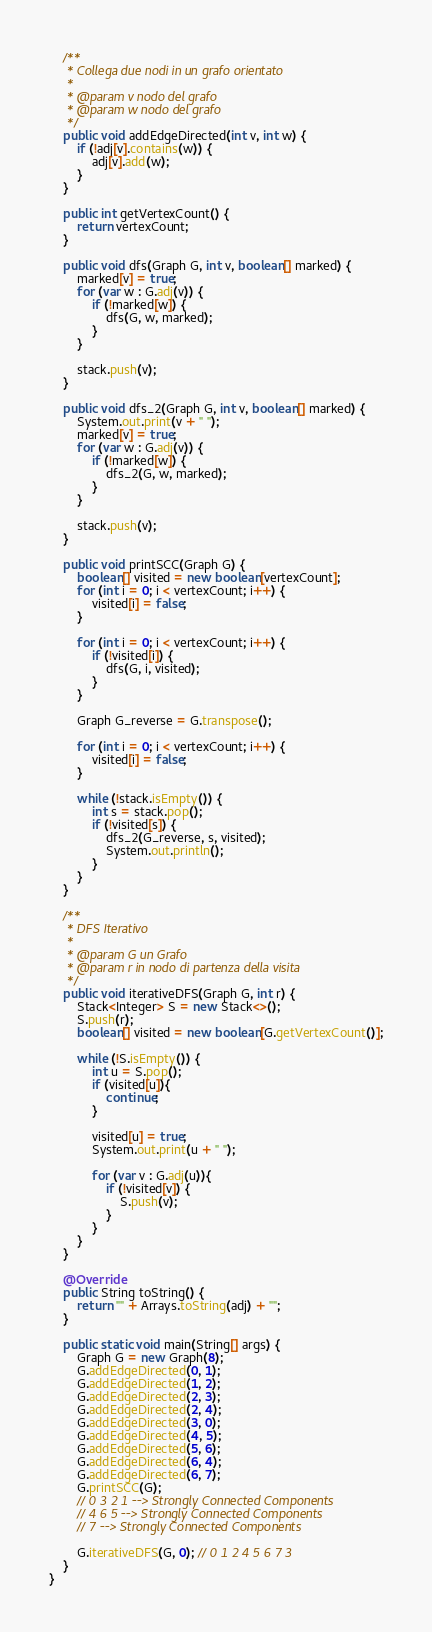<code> <loc_0><loc_0><loc_500><loc_500><_Java_>    /**
     * Collega due nodi in un grafo orientato
     *
     * @param v nodo del grafo
     * @param w nodo del grafo
     */
    public void addEdgeDirected(int v, int w) {
        if (!adj[v].contains(w)) {
            adj[v].add(w);
        }
    }

    public int getVertexCount() {
        return vertexCount;
    }

    public void dfs(Graph G, int v, boolean[] marked) {
        marked[v] = true;
        for (var w : G.adj(v)) {
            if (!marked[w]) {
                dfs(G, w, marked);
            }
        }

        stack.push(v);
    }

    public void dfs_2(Graph G, int v, boolean[] marked) {
        System.out.print(v + " ");
        marked[v] = true;
        for (var w : G.adj(v)) {
            if (!marked[w]) {
                dfs_2(G, w, marked);
            }
        }

        stack.push(v);
    }

    public void printSCC(Graph G) {
        boolean[] visited = new boolean[vertexCount];
        for (int i = 0; i < vertexCount; i++) {
            visited[i] = false;
        }

        for (int i = 0; i < vertexCount; i++) {
            if (!visited[i]) {
                dfs(G, i, visited);
            }
        }

        Graph G_reverse = G.transpose();

        for (int i = 0; i < vertexCount; i++) {
            visited[i] = false;
        }

        while (!stack.isEmpty()) {
            int s = stack.pop();
            if (!visited[s]) {
                dfs_2(G_reverse, s, visited);
                System.out.println();
            }
        }
    }

    /**
     * DFS Iterativo
     *
     * @param G un Grafo
     * @param r in nodo di partenza della visita
     */
    public void iterativeDFS(Graph G, int r) {
        Stack<Integer> S = new Stack<>();
        S.push(r);
        boolean[] visited = new boolean[G.getVertexCount()];

        while (!S.isEmpty()) {
            int u = S.pop();
            if (visited[u]){
                continue;
            }

            visited[u] = true;
            System.out.print(u + " ");

            for (var v : G.adj(u)){
                if (!visited[v]) {
                    S.push(v);
                }
            }
        }
    }

    @Override
    public String toString() {
        return "" + Arrays.toString(adj) + "";
    }

    public static void main(String[] args) {
        Graph G = new Graph(8);
        G.addEdgeDirected(0, 1);
        G.addEdgeDirected(1, 2);
        G.addEdgeDirected(2, 3);
        G.addEdgeDirected(2, 4);
        G.addEdgeDirected(3, 0);
        G.addEdgeDirected(4, 5);
        G.addEdgeDirected(5, 6);
        G.addEdgeDirected(6, 4);
        G.addEdgeDirected(6, 7);
        G.printSCC(G);
        // 0 3 2 1 --> Strongly Connected Components
        // 4 6 5 --> Strongly Connected Components
        // 7 --> Strongly Connected Components

        G.iterativeDFS(G, 0); // 0 1 2 4 5 6 7 3
    }
}
</code> 